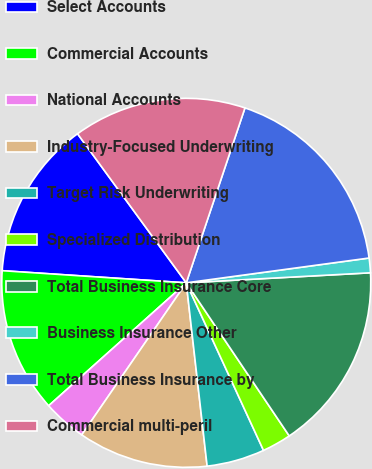Convert chart. <chart><loc_0><loc_0><loc_500><loc_500><pie_chart><fcel>Select Accounts<fcel>Commercial Accounts<fcel>National Accounts<fcel>Industry-Focused Underwriting<fcel>Target Risk Underwriting<fcel>Specialized Distribution<fcel>Total Business Insurance Core<fcel>Business Insurance Other<fcel>Total Business Insurance by<fcel>Commercial multi-peril<nl><fcel>13.92%<fcel>12.65%<fcel>3.81%<fcel>11.39%<fcel>5.07%<fcel>2.55%<fcel>16.44%<fcel>1.28%<fcel>17.7%<fcel>15.18%<nl></chart> 